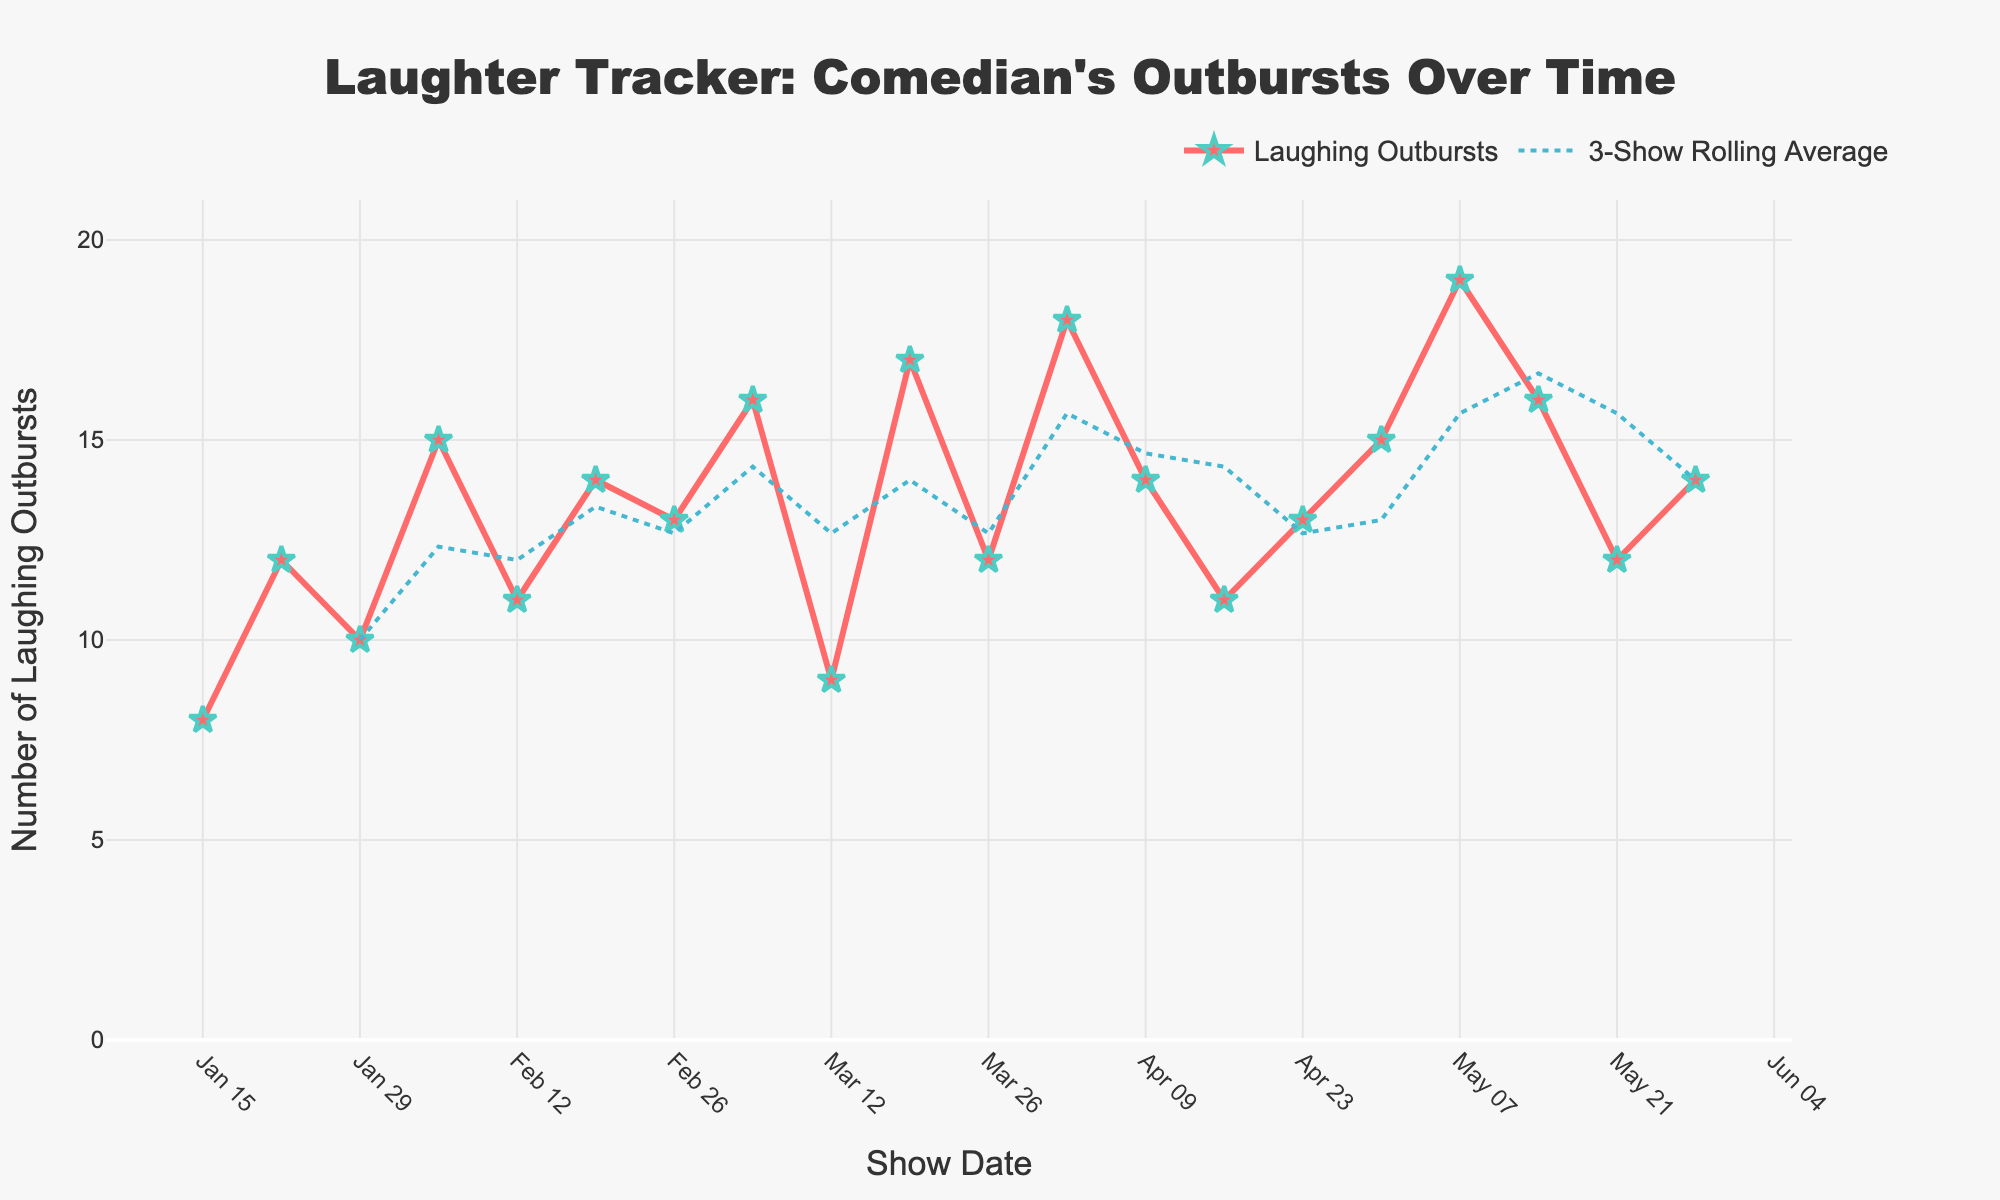What's the date with the highest number of laughing outbursts? The highest number of laughing outbursts is 19. On the x-axis, we see that this corresponds to the date 2023-05-07.
Answer: 2023-05-07 What is the average number of laughing outbursts across all tour dates? To calculate the average, sum all the laughing outbursts and divide by the number of dates. Sum is 278 (8 + 12 + 10 + 15 + 11 + 14 + 13 + 16 + 9 + 17 + 12 + 18 + 14 + 11 + 13 + 15 + 19 + 16 + 12 + 14). Divided by 20 dates, the average is approximately 13.9.
Answer: 13.9 On which date did the number of laughing outbursts first exceed the tour average? The average is approximately 13.9. The first date where the number of laughing outbursts exceeds this number is 2023-02-05, which has 15 outbursts.
Answer: 2023-02-05 How many times did the comedian have fewer than 10 laughing outbursts? Count all the dates with fewer than 10 laughing outbursts. These dates are 2023-01-15 (8 outbursts) and 2023-03-12 (9 outbursts). There are 2 such dates.
Answer: 2 What is the difference in the number of laughing outbursts between the highest and lowest dates? The highest value is 19 and the lowest is 8. The difference is 19 - 8.
Answer: 11 How many dates had laughing outbursts equal to or greater than 14? Count all the dates with laughing outbursts of 14 or greater. These are 2023-02-19 (14), 2023-03-05 (16), 2023-03-19 (17), 2023-04-02 (18), 2023-05-07 (19), 2023-05-14 (16), 2023-05-28 (14). There are 7 such dates.
Answer: 7 What is the maximum value of the 3-Show Rolling Average? Inspect the rolling average line and find the highest point. The maximum rolling average is approximately 17.0, seen close to 2023-05-07.
Answer: 17.0 Which date has the largest increase in laughing outbursts from the previous show? Find the date with the most significant jump from its preceding date. 2023-03-19 has 17 outbursts, following 2023-03-12 with 9 outbursts. The increase is 17 - 9 = 8.
Answer: 2023-03-19 Does any date have a laughing outburst count equal to the 3-show rolling average on the same date? Inspect the chart to see if any data points of the 'Laughing Outbursts' coincide with the '3-Show Rolling Average' line. This does not occur.
Answer: No What's the percentage increase in laughing outbursts from 2023-01-15 to 2023-05-07? Calculate the percentage increase: ((19 - 8) / 8) * 100%. This results in a 137.5% increase.
Answer: 137.5% 